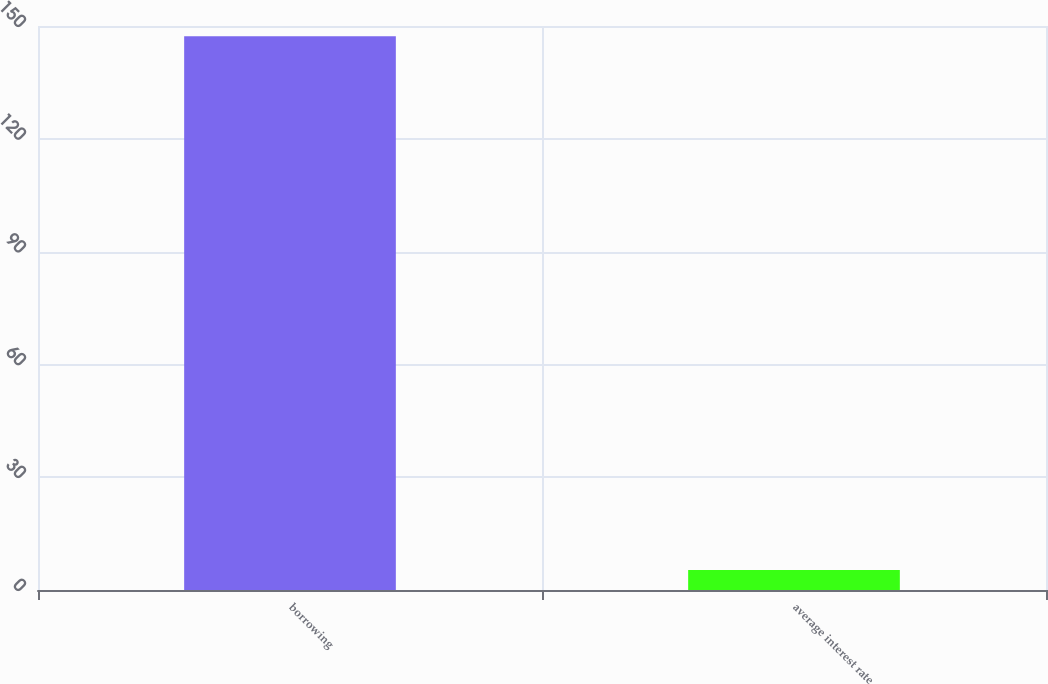Convert chart to OTSL. <chart><loc_0><loc_0><loc_500><loc_500><bar_chart><fcel>borrowing<fcel>average interest rate<nl><fcel>147.3<fcel>5.3<nl></chart> 